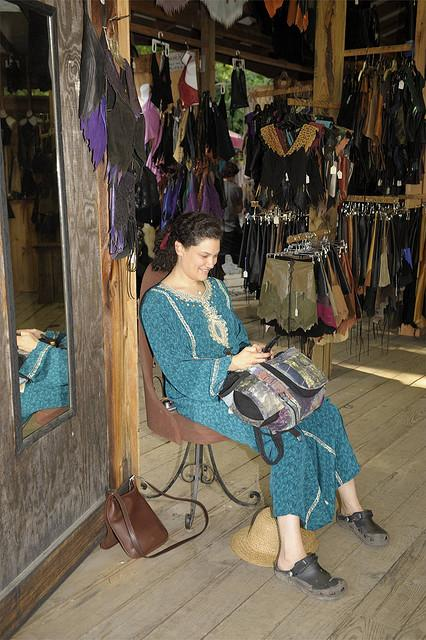What's the lady doing? texting 